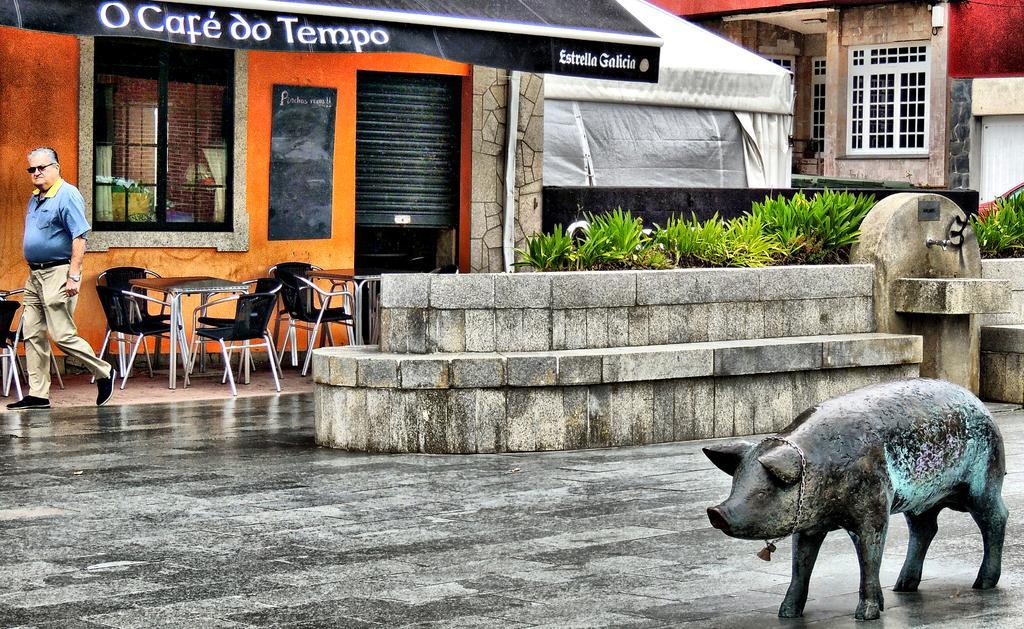Describe this image in one or two sentences. In this picture I can see a statue of a pig in front. In the background I can see a man, number of chairs and tables, few buildings, plants and on the left buildings I can see something is written and I can see the stone seat in the middle of this picture. 